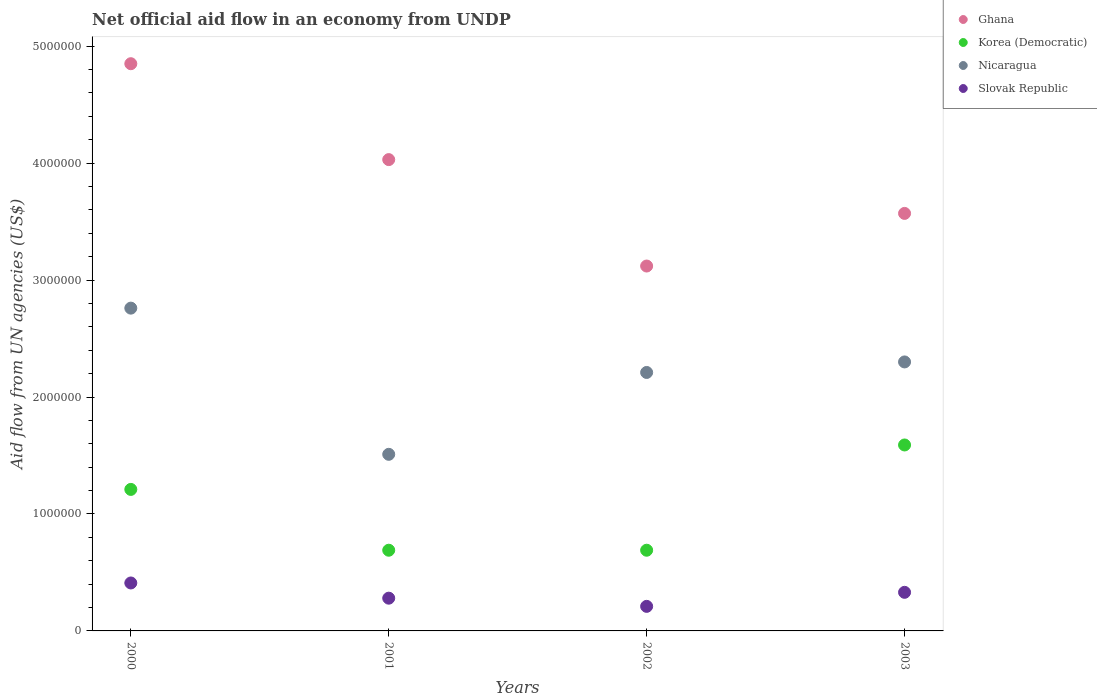Is the number of dotlines equal to the number of legend labels?
Offer a terse response. Yes. What is the net official aid flow in Korea (Democratic) in 2000?
Offer a very short reply. 1.21e+06. Across all years, what is the maximum net official aid flow in Korea (Democratic)?
Offer a very short reply. 1.59e+06. Across all years, what is the minimum net official aid flow in Slovak Republic?
Provide a short and direct response. 2.10e+05. In which year was the net official aid flow in Slovak Republic maximum?
Provide a short and direct response. 2000. In which year was the net official aid flow in Ghana minimum?
Provide a short and direct response. 2002. What is the total net official aid flow in Slovak Republic in the graph?
Provide a succinct answer. 1.23e+06. What is the difference between the net official aid flow in Ghana in 2002 and the net official aid flow in Korea (Democratic) in 2001?
Make the answer very short. 2.43e+06. What is the average net official aid flow in Ghana per year?
Provide a short and direct response. 3.89e+06. In the year 2003, what is the difference between the net official aid flow in Korea (Democratic) and net official aid flow in Nicaragua?
Your answer should be compact. -7.10e+05. In how many years, is the net official aid flow in Nicaragua greater than 3000000 US$?
Give a very brief answer. 0. What is the ratio of the net official aid flow in Slovak Republic in 2000 to that in 2003?
Ensure brevity in your answer.  1.24. Is the difference between the net official aid flow in Korea (Democratic) in 2000 and 2001 greater than the difference between the net official aid flow in Nicaragua in 2000 and 2001?
Provide a succinct answer. No. What is the difference between the highest and the second highest net official aid flow in Korea (Democratic)?
Make the answer very short. 3.80e+05. Is it the case that in every year, the sum of the net official aid flow in Ghana and net official aid flow in Slovak Republic  is greater than the sum of net official aid flow in Korea (Democratic) and net official aid flow in Nicaragua?
Your response must be concise. No. Is the net official aid flow in Ghana strictly less than the net official aid flow in Korea (Democratic) over the years?
Keep it short and to the point. No. How many dotlines are there?
Keep it short and to the point. 4. How many years are there in the graph?
Give a very brief answer. 4. Does the graph contain any zero values?
Offer a terse response. No. Where does the legend appear in the graph?
Keep it short and to the point. Top right. How are the legend labels stacked?
Give a very brief answer. Vertical. What is the title of the graph?
Your response must be concise. Net official aid flow in an economy from UNDP. What is the label or title of the X-axis?
Provide a succinct answer. Years. What is the label or title of the Y-axis?
Your response must be concise. Aid flow from UN agencies (US$). What is the Aid flow from UN agencies (US$) in Ghana in 2000?
Offer a terse response. 4.85e+06. What is the Aid flow from UN agencies (US$) of Korea (Democratic) in 2000?
Offer a very short reply. 1.21e+06. What is the Aid flow from UN agencies (US$) of Nicaragua in 2000?
Provide a succinct answer. 2.76e+06. What is the Aid flow from UN agencies (US$) in Ghana in 2001?
Keep it short and to the point. 4.03e+06. What is the Aid flow from UN agencies (US$) in Korea (Democratic) in 2001?
Make the answer very short. 6.90e+05. What is the Aid flow from UN agencies (US$) in Nicaragua in 2001?
Keep it short and to the point. 1.51e+06. What is the Aid flow from UN agencies (US$) in Slovak Republic in 2001?
Provide a short and direct response. 2.80e+05. What is the Aid flow from UN agencies (US$) of Ghana in 2002?
Offer a very short reply. 3.12e+06. What is the Aid flow from UN agencies (US$) of Korea (Democratic) in 2002?
Your answer should be very brief. 6.90e+05. What is the Aid flow from UN agencies (US$) of Nicaragua in 2002?
Ensure brevity in your answer.  2.21e+06. What is the Aid flow from UN agencies (US$) in Ghana in 2003?
Your answer should be compact. 3.57e+06. What is the Aid flow from UN agencies (US$) in Korea (Democratic) in 2003?
Offer a very short reply. 1.59e+06. What is the Aid flow from UN agencies (US$) of Nicaragua in 2003?
Provide a succinct answer. 2.30e+06. Across all years, what is the maximum Aid flow from UN agencies (US$) in Ghana?
Make the answer very short. 4.85e+06. Across all years, what is the maximum Aid flow from UN agencies (US$) in Korea (Democratic)?
Make the answer very short. 1.59e+06. Across all years, what is the maximum Aid flow from UN agencies (US$) of Nicaragua?
Your answer should be compact. 2.76e+06. Across all years, what is the minimum Aid flow from UN agencies (US$) in Ghana?
Your answer should be very brief. 3.12e+06. Across all years, what is the minimum Aid flow from UN agencies (US$) in Korea (Democratic)?
Offer a very short reply. 6.90e+05. Across all years, what is the minimum Aid flow from UN agencies (US$) of Nicaragua?
Make the answer very short. 1.51e+06. What is the total Aid flow from UN agencies (US$) in Ghana in the graph?
Offer a very short reply. 1.56e+07. What is the total Aid flow from UN agencies (US$) of Korea (Democratic) in the graph?
Make the answer very short. 4.18e+06. What is the total Aid flow from UN agencies (US$) in Nicaragua in the graph?
Keep it short and to the point. 8.78e+06. What is the total Aid flow from UN agencies (US$) of Slovak Republic in the graph?
Offer a terse response. 1.23e+06. What is the difference between the Aid flow from UN agencies (US$) in Ghana in 2000 and that in 2001?
Provide a succinct answer. 8.20e+05. What is the difference between the Aid flow from UN agencies (US$) of Korea (Democratic) in 2000 and that in 2001?
Make the answer very short. 5.20e+05. What is the difference between the Aid flow from UN agencies (US$) in Nicaragua in 2000 and that in 2001?
Provide a succinct answer. 1.25e+06. What is the difference between the Aid flow from UN agencies (US$) in Slovak Republic in 2000 and that in 2001?
Provide a succinct answer. 1.30e+05. What is the difference between the Aid flow from UN agencies (US$) of Ghana in 2000 and that in 2002?
Your answer should be very brief. 1.73e+06. What is the difference between the Aid flow from UN agencies (US$) in Korea (Democratic) in 2000 and that in 2002?
Give a very brief answer. 5.20e+05. What is the difference between the Aid flow from UN agencies (US$) of Nicaragua in 2000 and that in 2002?
Your answer should be compact. 5.50e+05. What is the difference between the Aid flow from UN agencies (US$) in Ghana in 2000 and that in 2003?
Ensure brevity in your answer.  1.28e+06. What is the difference between the Aid flow from UN agencies (US$) in Korea (Democratic) in 2000 and that in 2003?
Your answer should be compact. -3.80e+05. What is the difference between the Aid flow from UN agencies (US$) in Nicaragua in 2000 and that in 2003?
Ensure brevity in your answer.  4.60e+05. What is the difference between the Aid flow from UN agencies (US$) of Slovak Republic in 2000 and that in 2003?
Your answer should be compact. 8.00e+04. What is the difference between the Aid flow from UN agencies (US$) of Ghana in 2001 and that in 2002?
Keep it short and to the point. 9.10e+05. What is the difference between the Aid flow from UN agencies (US$) in Nicaragua in 2001 and that in 2002?
Make the answer very short. -7.00e+05. What is the difference between the Aid flow from UN agencies (US$) of Korea (Democratic) in 2001 and that in 2003?
Keep it short and to the point. -9.00e+05. What is the difference between the Aid flow from UN agencies (US$) of Nicaragua in 2001 and that in 2003?
Offer a very short reply. -7.90e+05. What is the difference between the Aid flow from UN agencies (US$) of Slovak Republic in 2001 and that in 2003?
Offer a terse response. -5.00e+04. What is the difference between the Aid flow from UN agencies (US$) in Ghana in 2002 and that in 2003?
Offer a very short reply. -4.50e+05. What is the difference between the Aid flow from UN agencies (US$) of Korea (Democratic) in 2002 and that in 2003?
Keep it short and to the point. -9.00e+05. What is the difference between the Aid flow from UN agencies (US$) in Ghana in 2000 and the Aid flow from UN agencies (US$) in Korea (Democratic) in 2001?
Offer a terse response. 4.16e+06. What is the difference between the Aid flow from UN agencies (US$) in Ghana in 2000 and the Aid flow from UN agencies (US$) in Nicaragua in 2001?
Your answer should be compact. 3.34e+06. What is the difference between the Aid flow from UN agencies (US$) in Ghana in 2000 and the Aid flow from UN agencies (US$) in Slovak Republic in 2001?
Make the answer very short. 4.57e+06. What is the difference between the Aid flow from UN agencies (US$) in Korea (Democratic) in 2000 and the Aid flow from UN agencies (US$) in Nicaragua in 2001?
Provide a short and direct response. -3.00e+05. What is the difference between the Aid flow from UN agencies (US$) in Korea (Democratic) in 2000 and the Aid flow from UN agencies (US$) in Slovak Republic in 2001?
Your answer should be compact. 9.30e+05. What is the difference between the Aid flow from UN agencies (US$) in Nicaragua in 2000 and the Aid flow from UN agencies (US$) in Slovak Republic in 2001?
Your answer should be very brief. 2.48e+06. What is the difference between the Aid flow from UN agencies (US$) of Ghana in 2000 and the Aid flow from UN agencies (US$) of Korea (Democratic) in 2002?
Keep it short and to the point. 4.16e+06. What is the difference between the Aid flow from UN agencies (US$) of Ghana in 2000 and the Aid flow from UN agencies (US$) of Nicaragua in 2002?
Offer a terse response. 2.64e+06. What is the difference between the Aid flow from UN agencies (US$) of Ghana in 2000 and the Aid flow from UN agencies (US$) of Slovak Republic in 2002?
Your answer should be very brief. 4.64e+06. What is the difference between the Aid flow from UN agencies (US$) of Korea (Democratic) in 2000 and the Aid flow from UN agencies (US$) of Nicaragua in 2002?
Provide a succinct answer. -1.00e+06. What is the difference between the Aid flow from UN agencies (US$) of Nicaragua in 2000 and the Aid flow from UN agencies (US$) of Slovak Republic in 2002?
Your response must be concise. 2.55e+06. What is the difference between the Aid flow from UN agencies (US$) in Ghana in 2000 and the Aid flow from UN agencies (US$) in Korea (Democratic) in 2003?
Offer a very short reply. 3.26e+06. What is the difference between the Aid flow from UN agencies (US$) of Ghana in 2000 and the Aid flow from UN agencies (US$) of Nicaragua in 2003?
Offer a very short reply. 2.55e+06. What is the difference between the Aid flow from UN agencies (US$) of Ghana in 2000 and the Aid flow from UN agencies (US$) of Slovak Republic in 2003?
Keep it short and to the point. 4.52e+06. What is the difference between the Aid flow from UN agencies (US$) in Korea (Democratic) in 2000 and the Aid flow from UN agencies (US$) in Nicaragua in 2003?
Ensure brevity in your answer.  -1.09e+06. What is the difference between the Aid flow from UN agencies (US$) in Korea (Democratic) in 2000 and the Aid flow from UN agencies (US$) in Slovak Republic in 2003?
Your response must be concise. 8.80e+05. What is the difference between the Aid flow from UN agencies (US$) of Nicaragua in 2000 and the Aid flow from UN agencies (US$) of Slovak Republic in 2003?
Your response must be concise. 2.43e+06. What is the difference between the Aid flow from UN agencies (US$) of Ghana in 2001 and the Aid flow from UN agencies (US$) of Korea (Democratic) in 2002?
Your answer should be very brief. 3.34e+06. What is the difference between the Aid flow from UN agencies (US$) in Ghana in 2001 and the Aid flow from UN agencies (US$) in Nicaragua in 2002?
Your answer should be very brief. 1.82e+06. What is the difference between the Aid flow from UN agencies (US$) in Ghana in 2001 and the Aid flow from UN agencies (US$) in Slovak Republic in 2002?
Provide a short and direct response. 3.82e+06. What is the difference between the Aid flow from UN agencies (US$) of Korea (Democratic) in 2001 and the Aid flow from UN agencies (US$) of Nicaragua in 2002?
Make the answer very short. -1.52e+06. What is the difference between the Aid flow from UN agencies (US$) in Nicaragua in 2001 and the Aid flow from UN agencies (US$) in Slovak Republic in 2002?
Provide a short and direct response. 1.30e+06. What is the difference between the Aid flow from UN agencies (US$) of Ghana in 2001 and the Aid flow from UN agencies (US$) of Korea (Democratic) in 2003?
Your answer should be very brief. 2.44e+06. What is the difference between the Aid flow from UN agencies (US$) of Ghana in 2001 and the Aid flow from UN agencies (US$) of Nicaragua in 2003?
Provide a short and direct response. 1.73e+06. What is the difference between the Aid flow from UN agencies (US$) of Ghana in 2001 and the Aid flow from UN agencies (US$) of Slovak Republic in 2003?
Offer a terse response. 3.70e+06. What is the difference between the Aid flow from UN agencies (US$) in Korea (Democratic) in 2001 and the Aid flow from UN agencies (US$) in Nicaragua in 2003?
Your answer should be very brief. -1.61e+06. What is the difference between the Aid flow from UN agencies (US$) in Nicaragua in 2001 and the Aid flow from UN agencies (US$) in Slovak Republic in 2003?
Your answer should be compact. 1.18e+06. What is the difference between the Aid flow from UN agencies (US$) of Ghana in 2002 and the Aid flow from UN agencies (US$) of Korea (Democratic) in 2003?
Provide a short and direct response. 1.53e+06. What is the difference between the Aid flow from UN agencies (US$) in Ghana in 2002 and the Aid flow from UN agencies (US$) in Nicaragua in 2003?
Make the answer very short. 8.20e+05. What is the difference between the Aid flow from UN agencies (US$) of Ghana in 2002 and the Aid flow from UN agencies (US$) of Slovak Republic in 2003?
Your answer should be compact. 2.79e+06. What is the difference between the Aid flow from UN agencies (US$) in Korea (Democratic) in 2002 and the Aid flow from UN agencies (US$) in Nicaragua in 2003?
Make the answer very short. -1.61e+06. What is the difference between the Aid flow from UN agencies (US$) of Nicaragua in 2002 and the Aid flow from UN agencies (US$) of Slovak Republic in 2003?
Give a very brief answer. 1.88e+06. What is the average Aid flow from UN agencies (US$) of Ghana per year?
Offer a very short reply. 3.89e+06. What is the average Aid flow from UN agencies (US$) of Korea (Democratic) per year?
Ensure brevity in your answer.  1.04e+06. What is the average Aid flow from UN agencies (US$) of Nicaragua per year?
Your answer should be very brief. 2.20e+06. What is the average Aid flow from UN agencies (US$) of Slovak Republic per year?
Provide a succinct answer. 3.08e+05. In the year 2000, what is the difference between the Aid flow from UN agencies (US$) in Ghana and Aid flow from UN agencies (US$) in Korea (Democratic)?
Offer a very short reply. 3.64e+06. In the year 2000, what is the difference between the Aid flow from UN agencies (US$) of Ghana and Aid flow from UN agencies (US$) of Nicaragua?
Give a very brief answer. 2.09e+06. In the year 2000, what is the difference between the Aid flow from UN agencies (US$) in Ghana and Aid flow from UN agencies (US$) in Slovak Republic?
Provide a succinct answer. 4.44e+06. In the year 2000, what is the difference between the Aid flow from UN agencies (US$) of Korea (Democratic) and Aid flow from UN agencies (US$) of Nicaragua?
Give a very brief answer. -1.55e+06. In the year 2000, what is the difference between the Aid flow from UN agencies (US$) in Korea (Democratic) and Aid flow from UN agencies (US$) in Slovak Republic?
Provide a short and direct response. 8.00e+05. In the year 2000, what is the difference between the Aid flow from UN agencies (US$) of Nicaragua and Aid flow from UN agencies (US$) of Slovak Republic?
Ensure brevity in your answer.  2.35e+06. In the year 2001, what is the difference between the Aid flow from UN agencies (US$) of Ghana and Aid flow from UN agencies (US$) of Korea (Democratic)?
Offer a very short reply. 3.34e+06. In the year 2001, what is the difference between the Aid flow from UN agencies (US$) in Ghana and Aid flow from UN agencies (US$) in Nicaragua?
Ensure brevity in your answer.  2.52e+06. In the year 2001, what is the difference between the Aid flow from UN agencies (US$) in Ghana and Aid flow from UN agencies (US$) in Slovak Republic?
Provide a short and direct response. 3.75e+06. In the year 2001, what is the difference between the Aid flow from UN agencies (US$) of Korea (Democratic) and Aid flow from UN agencies (US$) of Nicaragua?
Make the answer very short. -8.20e+05. In the year 2001, what is the difference between the Aid flow from UN agencies (US$) of Korea (Democratic) and Aid flow from UN agencies (US$) of Slovak Republic?
Give a very brief answer. 4.10e+05. In the year 2001, what is the difference between the Aid flow from UN agencies (US$) of Nicaragua and Aid flow from UN agencies (US$) of Slovak Republic?
Ensure brevity in your answer.  1.23e+06. In the year 2002, what is the difference between the Aid flow from UN agencies (US$) in Ghana and Aid flow from UN agencies (US$) in Korea (Democratic)?
Provide a short and direct response. 2.43e+06. In the year 2002, what is the difference between the Aid flow from UN agencies (US$) of Ghana and Aid flow from UN agencies (US$) of Nicaragua?
Provide a short and direct response. 9.10e+05. In the year 2002, what is the difference between the Aid flow from UN agencies (US$) in Ghana and Aid flow from UN agencies (US$) in Slovak Republic?
Offer a very short reply. 2.91e+06. In the year 2002, what is the difference between the Aid flow from UN agencies (US$) in Korea (Democratic) and Aid flow from UN agencies (US$) in Nicaragua?
Provide a short and direct response. -1.52e+06. In the year 2002, what is the difference between the Aid flow from UN agencies (US$) of Korea (Democratic) and Aid flow from UN agencies (US$) of Slovak Republic?
Your answer should be very brief. 4.80e+05. In the year 2003, what is the difference between the Aid flow from UN agencies (US$) in Ghana and Aid flow from UN agencies (US$) in Korea (Democratic)?
Your response must be concise. 1.98e+06. In the year 2003, what is the difference between the Aid flow from UN agencies (US$) in Ghana and Aid flow from UN agencies (US$) in Nicaragua?
Your answer should be compact. 1.27e+06. In the year 2003, what is the difference between the Aid flow from UN agencies (US$) of Ghana and Aid flow from UN agencies (US$) of Slovak Republic?
Ensure brevity in your answer.  3.24e+06. In the year 2003, what is the difference between the Aid flow from UN agencies (US$) of Korea (Democratic) and Aid flow from UN agencies (US$) of Nicaragua?
Give a very brief answer. -7.10e+05. In the year 2003, what is the difference between the Aid flow from UN agencies (US$) of Korea (Democratic) and Aid flow from UN agencies (US$) of Slovak Republic?
Provide a succinct answer. 1.26e+06. In the year 2003, what is the difference between the Aid flow from UN agencies (US$) of Nicaragua and Aid flow from UN agencies (US$) of Slovak Republic?
Offer a terse response. 1.97e+06. What is the ratio of the Aid flow from UN agencies (US$) in Ghana in 2000 to that in 2001?
Provide a short and direct response. 1.2. What is the ratio of the Aid flow from UN agencies (US$) of Korea (Democratic) in 2000 to that in 2001?
Keep it short and to the point. 1.75. What is the ratio of the Aid flow from UN agencies (US$) in Nicaragua in 2000 to that in 2001?
Provide a short and direct response. 1.83. What is the ratio of the Aid flow from UN agencies (US$) of Slovak Republic in 2000 to that in 2001?
Provide a short and direct response. 1.46. What is the ratio of the Aid flow from UN agencies (US$) in Ghana in 2000 to that in 2002?
Your answer should be compact. 1.55. What is the ratio of the Aid flow from UN agencies (US$) of Korea (Democratic) in 2000 to that in 2002?
Ensure brevity in your answer.  1.75. What is the ratio of the Aid flow from UN agencies (US$) of Nicaragua in 2000 to that in 2002?
Keep it short and to the point. 1.25. What is the ratio of the Aid flow from UN agencies (US$) in Slovak Republic in 2000 to that in 2002?
Make the answer very short. 1.95. What is the ratio of the Aid flow from UN agencies (US$) of Ghana in 2000 to that in 2003?
Keep it short and to the point. 1.36. What is the ratio of the Aid flow from UN agencies (US$) in Korea (Democratic) in 2000 to that in 2003?
Provide a short and direct response. 0.76. What is the ratio of the Aid flow from UN agencies (US$) of Slovak Republic in 2000 to that in 2003?
Your answer should be compact. 1.24. What is the ratio of the Aid flow from UN agencies (US$) in Ghana in 2001 to that in 2002?
Provide a succinct answer. 1.29. What is the ratio of the Aid flow from UN agencies (US$) in Korea (Democratic) in 2001 to that in 2002?
Ensure brevity in your answer.  1. What is the ratio of the Aid flow from UN agencies (US$) in Nicaragua in 2001 to that in 2002?
Your answer should be very brief. 0.68. What is the ratio of the Aid flow from UN agencies (US$) of Slovak Republic in 2001 to that in 2002?
Offer a very short reply. 1.33. What is the ratio of the Aid flow from UN agencies (US$) in Ghana in 2001 to that in 2003?
Offer a terse response. 1.13. What is the ratio of the Aid flow from UN agencies (US$) in Korea (Democratic) in 2001 to that in 2003?
Ensure brevity in your answer.  0.43. What is the ratio of the Aid flow from UN agencies (US$) of Nicaragua in 2001 to that in 2003?
Provide a succinct answer. 0.66. What is the ratio of the Aid flow from UN agencies (US$) in Slovak Republic in 2001 to that in 2003?
Make the answer very short. 0.85. What is the ratio of the Aid flow from UN agencies (US$) of Ghana in 2002 to that in 2003?
Provide a short and direct response. 0.87. What is the ratio of the Aid flow from UN agencies (US$) in Korea (Democratic) in 2002 to that in 2003?
Make the answer very short. 0.43. What is the ratio of the Aid flow from UN agencies (US$) of Nicaragua in 2002 to that in 2003?
Offer a very short reply. 0.96. What is the ratio of the Aid flow from UN agencies (US$) of Slovak Republic in 2002 to that in 2003?
Offer a terse response. 0.64. What is the difference between the highest and the second highest Aid flow from UN agencies (US$) in Ghana?
Keep it short and to the point. 8.20e+05. What is the difference between the highest and the second highest Aid flow from UN agencies (US$) in Nicaragua?
Provide a succinct answer. 4.60e+05. What is the difference between the highest and the second highest Aid flow from UN agencies (US$) in Slovak Republic?
Offer a very short reply. 8.00e+04. What is the difference between the highest and the lowest Aid flow from UN agencies (US$) of Ghana?
Give a very brief answer. 1.73e+06. What is the difference between the highest and the lowest Aid flow from UN agencies (US$) of Nicaragua?
Make the answer very short. 1.25e+06. What is the difference between the highest and the lowest Aid flow from UN agencies (US$) in Slovak Republic?
Your response must be concise. 2.00e+05. 